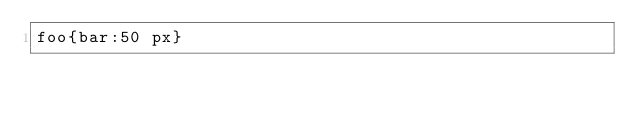<code> <loc_0><loc_0><loc_500><loc_500><_CSS_>foo{bar:50 px}
</code> 